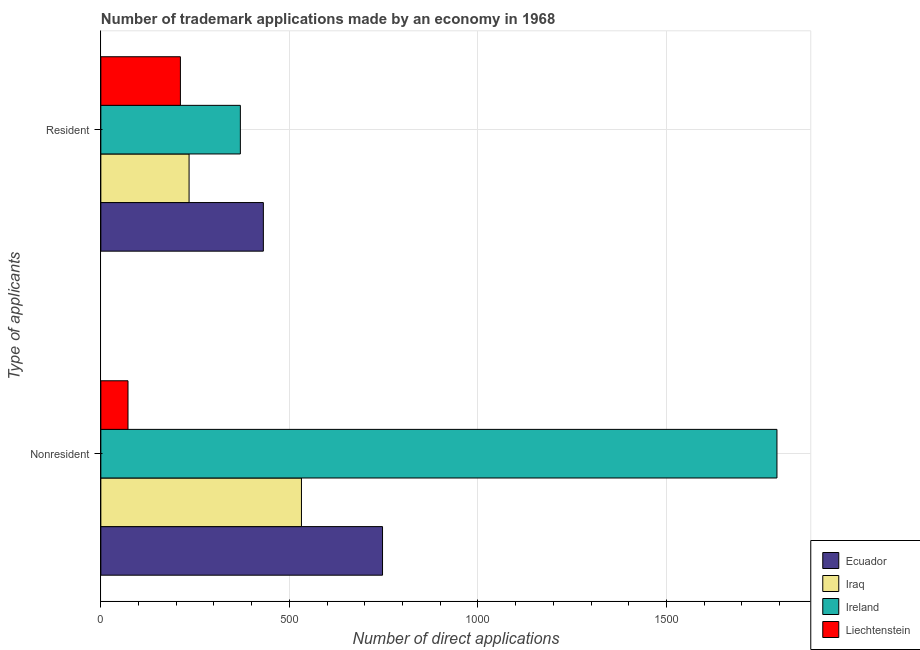How many groups of bars are there?
Keep it short and to the point. 2. Are the number of bars on each tick of the Y-axis equal?
Offer a terse response. Yes. How many bars are there on the 1st tick from the bottom?
Your answer should be very brief. 4. What is the label of the 2nd group of bars from the top?
Offer a very short reply. Nonresident. What is the number of trademark applications made by non residents in Ecuador?
Your response must be concise. 747. Across all countries, what is the maximum number of trademark applications made by residents?
Provide a succinct answer. 431. Across all countries, what is the minimum number of trademark applications made by residents?
Give a very brief answer. 211. In which country was the number of trademark applications made by non residents maximum?
Provide a short and direct response. Ireland. In which country was the number of trademark applications made by non residents minimum?
Provide a short and direct response. Liechtenstein. What is the total number of trademark applications made by residents in the graph?
Offer a very short reply. 1246. What is the difference between the number of trademark applications made by non residents in Iraq and that in Liechtenstein?
Your answer should be very brief. 460. What is the difference between the number of trademark applications made by non residents in Ecuador and the number of trademark applications made by residents in Iraq?
Provide a succinct answer. 513. What is the average number of trademark applications made by residents per country?
Your answer should be very brief. 311.5. What is the difference between the number of trademark applications made by non residents and number of trademark applications made by residents in Ireland?
Provide a short and direct response. 1423. What is the ratio of the number of trademark applications made by residents in Ireland to that in Ecuador?
Make the answer very short. 0.86. Is the number of trademark applications made by non residents in Liechtenstein less than that in Ecuador?
Make the answer very short. Yes. What does the 3rd bar from the top in Resident represents?
Make the answer very short. Iraq. What does the 2nd bar from the bottom in Nonresident represents?
Ensure brevity in your answer.  Iraq. How many bars are there?
Offer a terse response. 8. How many countries are there in the graph?
Give a very brief answer. 4. Are the values on the major ticks of X-axis written in scientific E-notation?
Your response must be concise. No. Does the graph contain any zero values?
Ensure brevity in your answer.  No. Does the graph contain grids?
Give a very brief answer. Yes. What is the title of the graph?
Make the answer very short. Number of trademark applications made by an economy in 1968. What is the label or title of the X-axis?
Provide a succinct answer. Number of direct applications. What is the label or title of the Y-axis?
Make the answer very short. Type of applicants. What is the Number of direct applications in Ecuador in Nonresident?
Provide a short and direct response. 747. What is the Number of direct applications in Iraq in Nonresident?
Your answer should be very brief. 532. What is the Number of direct applications in Ireland in Nonresident?
Your answer should be very brief. 1793. What is the Number of direct applications in Liechtenstein in Nonresident?
Make the answer very short. 72. What is the Number of direct applications of Ecuador in Resident?
Keep it short and to the point. 431. What is the Number of direct applications of Iraq in Resident?
Ensure brevity in your answer.  234. What is the Number of direct applications of Ireland in Resident?
Your answer should be compact. 370. What is the Number of direct applications of Liechtenstein in Resident?
Give a very brief answer. 211. Across all Type of applicants, what is the maximum Number of direct applications of Ecuador?
Offer a terse response. 747. Across all Type of applicants, what is the maximum Number of direct applications in Iraq?
Give a very brief answer. 532. Across all Type of applicants, what is the maximum Number of direct applications in Ireland?
Provide a succinct answer. 1793. Across all Type of applicants, what is the maximum Number of direct applications in Liechtenstein?
Provide a succinct answer. 211. Across all Type of applicants, what is the minimum Number of direct applications in Ecuador?
Offer a very short reply. 431. Across all Type of applicants, what is the minimum Number of direct applications in Iraq?
Keep it short and to the point. 234. Across all Type of applicants, what is the minimum Number of direct applications in Ireland?
Offer a terse response. 370. What is the total Number of direct applications of Ecuador in the graph?
Keep it short and to the point. 1178. What is the total Number of direct applications of Iraq in the graph?
Keep it short and to the point. 766. What is the total Number of direct applications in Ireland in the graph?
Give a very brief answer. 2163. What is the total Number of direct applications of Liechtenstein in the graph?
Your answer should be very brief. 283. What is the difference between the Number of direct applications of Ecuador in Nonresident and that in Resident?
Provide a succinct answer. 316. What is the difference between the Number of direct applications of Iraq in Nonresident and that in Resident?
Your response must be concise. 298. What is the difference between the Number of direct applications in Ireland in Nonresident and that in Resident?
Make the answer very short. 1423. What is the difference between the Number of direct applications of Liechtenstein in Nonresident and that in Resident?
Give a very brief answer. -139. What is the difference between the Number of direct applications of Ecuador in Nonresident and the Number of direct applications of Iraq in Resident?
Your answer should be very brief. 513. What is the difference between the Number of direct applications of Ecuador in Nonresident and the Number of direct applications of Ireland in Resident?
Provide a succinct answer. 377. What is the difference between the Number of direct applications in Ecuador in Nonresident and the Number of direct applications in Liechtenstein in Resident?
Keep it short and to the point. 536. What is the difference between the Number of direct applications of Iraq in Nonresident and the Number of direct applications of Ireland in Resident?
Make the answer very short. 162. What is the difference between the Number of direct applications in Iraq in Nonresident and the Number of direct applications in Liechtenstein in Resident?
Your response must be concise. 321. What is the difference between the Number of direct applications of Ireland in Nonresident and the Number of direct applications of Liechtenstein in Resident?
Your answer should be compact. 1582. What is the average Number of direct applications in Ecuador per Type of applicants?
Provide a succinct answer. 589. What is the average Number of direct applications in Iraq per Type of applicants?
Make the answer very short. 383. What is the average Number of direct applications in Ireland per Type of applicants?
Provide a short and direct response. 1081.5. What is the average Number of direct applications of Liechtenstein per Type of applicants?
Your response must be concise. 141.5. What is the difference between the Number of direct applications of Ecuador and Number of direct applications of Iraq in Nonresident?
Provide a succinct answer. 215. What is the difference between the Number of direct applications of Ecuador and Number of direct applications of Ireland in Nonresident?
Offer a very short reply. -1046. What is the difference between the Number of direct applications of Ecuador and Number of direct applications of Liechtenstein in Nonresident?
Make the answer very short. 675. What is the difference between the Number of direct applications in Iraq and Number of direct applications in Ireland in Nonresident?
Offer a very short reply. -1261. What is the difference between the Number of direct applications in Iraq and Number of direct applications in Liechtenstein in Nonresident?
Provide a short and direct response. 460. What is the difference between the Number of direct applications of Ireland and Number of direct applications of Liechtenstein in Nonresident?
Give a very brief answer. 1721. What is the difference between the Number of direct applications of Ecuador and Number of direct applications of Iraq in Resident?
Your answer should be very brief. 197. What is the difference between the Number of direct applications in Ecuador and Number of direct applications in Liechtenstein in Resident?
Keep it short and to the point. 220. What is the difference between the Number of direct applications of Iraq and Number of direct applications of Ireland in Resident?
Provide a short and direct response. -136. What is the difference between the Number of direct applications of Ireland and Number of direct applications of Liechtenstein in Resident?
Provide a succinct answer. 159. What is the ratio of the Number of direct applications of Ecuador in Nonresident to that in Resident?
Provide a short and direct response. 1.73. What is the ratio of the Number of direct applications of Iraq in Nonresident to that in Resident?
Your response must be concise. 2.27. What is the ratio of the Number of direct applications of Ireland in Nonresident to that in Resident?
Provide a succinct answer. 4.85. What is the ratio of the Number of direct applications in Liechtenstein in Nonresident to that in Resident?
Offer a very short reply. 0.34. What is the difference between the highest and the second highest Number of direct applications of Ecuador?
Provide a succinct answer. 316. What is the difference between the highest and the second highest Number of direct applications in Iraq?
Give a very brief answer. 298. What is the difference between the highest and the second highest Number of direct applications of Ireland?
Give a very brief answer. 1423. What is the difference between the highest and the second highest Number of direct applications in Liechtenstein?
Provide a short and direct response. 139. What is the difference between the highest and the lowest Number of direct applications in Ecuador?
Keep it short and to the point. 316. What is the difference between the highest and the lowest Number of direct applications in Iraq?
Give a very brief answer. 298. What is the difference between the highest and the lowest Number of direct applications of Ireland?
Make the answer very short. 1423. What is the difference between the highest and the lowest Number of direct applications of Liechtenstein?
Ensure brevity in your answer.  139. 